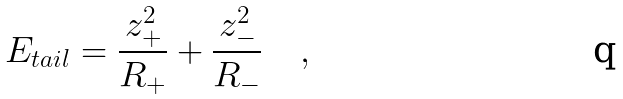Convert formula to latex. <formula><loc_0><loc_0><loc_500><loc_500>E _ { t a i l } = \frac { z _ { + } ^ { 2 } } { R _ { + } } + \frac { z _ { - } ^ { 2 } } { R _ { - } } \quad ,</formula> 